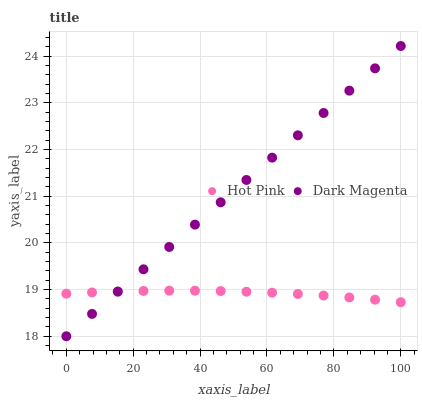Does Hot Pink have the minimum area under the curve?
Answer yes or no. Yes. Does Dark Magenta have the maximum area under the curve?
Answer yes or no. Yes. Does Dark Magenta have the minimum area under the curve?
Answer yes or no. No. Is Dark Magenta the smoothest?
Answer yes or no. Yes. Is Hot Pink the roughest?
Answer yes or no. Yes. Is Dark Magenta the roughest?
Answer yes or no. No. Does Dark Magenta have the lowest value?
Answer yes or no. Yes. Does Dark Magenta have the highest value?
Answer yes or no. Yes. Does Hot Pink intersect Dark Magenta?
Answer yes or no. Yes. Is Hot Pink less than Dark Magenta?
Answer yes or no. No. Is Hot Pink greater than Dark Magenta?
Answer yes or no. No. 